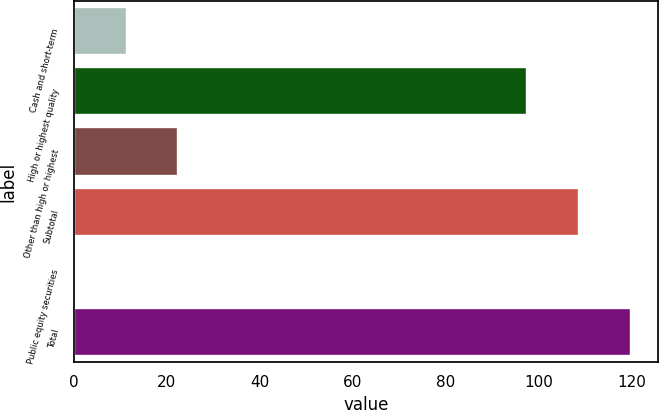Convert chart to OTSL. <chart><loc_0><loc_0><loc_500><loc_500><bar_chart><fcel>Cash and short-term<fcel>High or highest quality<fcel>Other than high or highest<fcel>Subtotal<fcel>Public equity securities<fcel>Total<nl><fcel>11.41<fcel>97.6<fcel>22.52<fcel>108.71<fcel>0.3<fcel>119.82<nl></chart> 